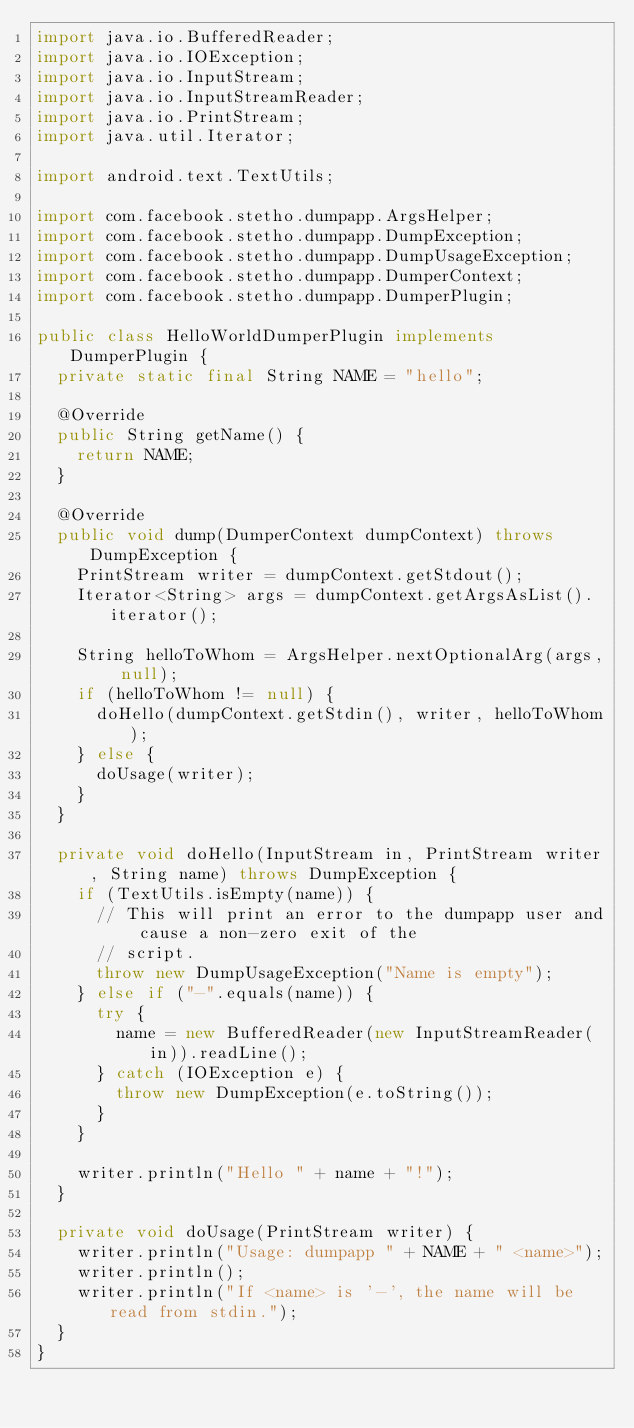Convert code to text. <code><loc_0><loc_0><loc_500><loc_500><_Java_>import java.io.BufferedReader;
import java.io.IOException;
import java.io.InputStream;
import java.io.InputStreamReader;
import java.io.PrintStream;
import java.util.Iterator;

import android.text.TextUtils;

import com.facebook.stetho.dumpapp.ArgsHelper;
import com.facebook.stetho.dumpapp.DumpException;
import com.facebook.stetho.dumpapp.DumpUsageException;
import com.facebook.stetho.dumpapp.DumperContext;
import com.facebook.stetho.dumpapp.DumperPlugin;

public class HelloWorldDumperPlugin implements DumperPlugin {
  private static final String NAME = "hello";

  @Override
  public String getName() {
    return NAME;
  }

  @Override
  public void dump(DumperContext dumpContext) throws DumpException {
    PrintStream writer = dumpContext.getStdout();
    Iterator<String> args = dumpContext.getArgsAsList().iterator();

    String helloToWhom = ArgsHelper.nextOptionalArg(args, null);
    if (helloToWhom != null) {
      doHello(dumpContext.getStdin(), writer, helloToWhom);
    } else {
      doUsage(writer);
    }
  }

  private void doHello(InputStream in, PrintStream writer, String name) throws DumpException {
    if (TextUtils.isEmpty(name)) {
      // This will print an error to the dumpapp user and cause a non-zero exit of the
      // script.
      throw new DumpUsageException("Name is empty");
    } else if ("-".equals(name)) {
      try {
        name = new BufferedReader(new InputStreamReader(in)).readLine();
      } catch (IOException e) {
        throw new DumpException(e.toString());
      }
    }

    writer.println("Hello " + name + "!");
  }

  private void doUsage(PrintStream writer) {
    writer.println("Usage: dumpapp " + NAME + " <name>");
    writer.println();
    writer.println("If <name> is '-', the name will be read from stdin.");
  }
}
</code> 